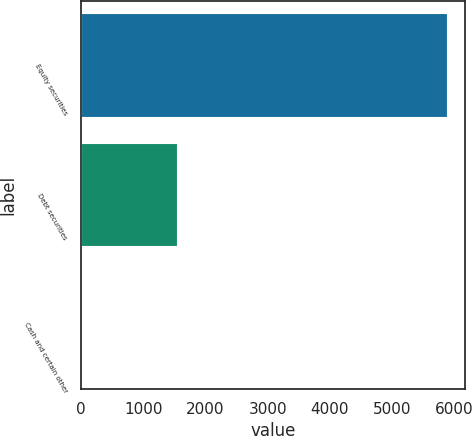Convert chart. <chart><loc_0><loc_0><loc_500><loc_500><bar_chart><fcel>Equity securities<fcel>Debt securities<fcel>Cash and certain other<nl><fcel>5885<fcel>1542<fcel>5<nl></chart> 